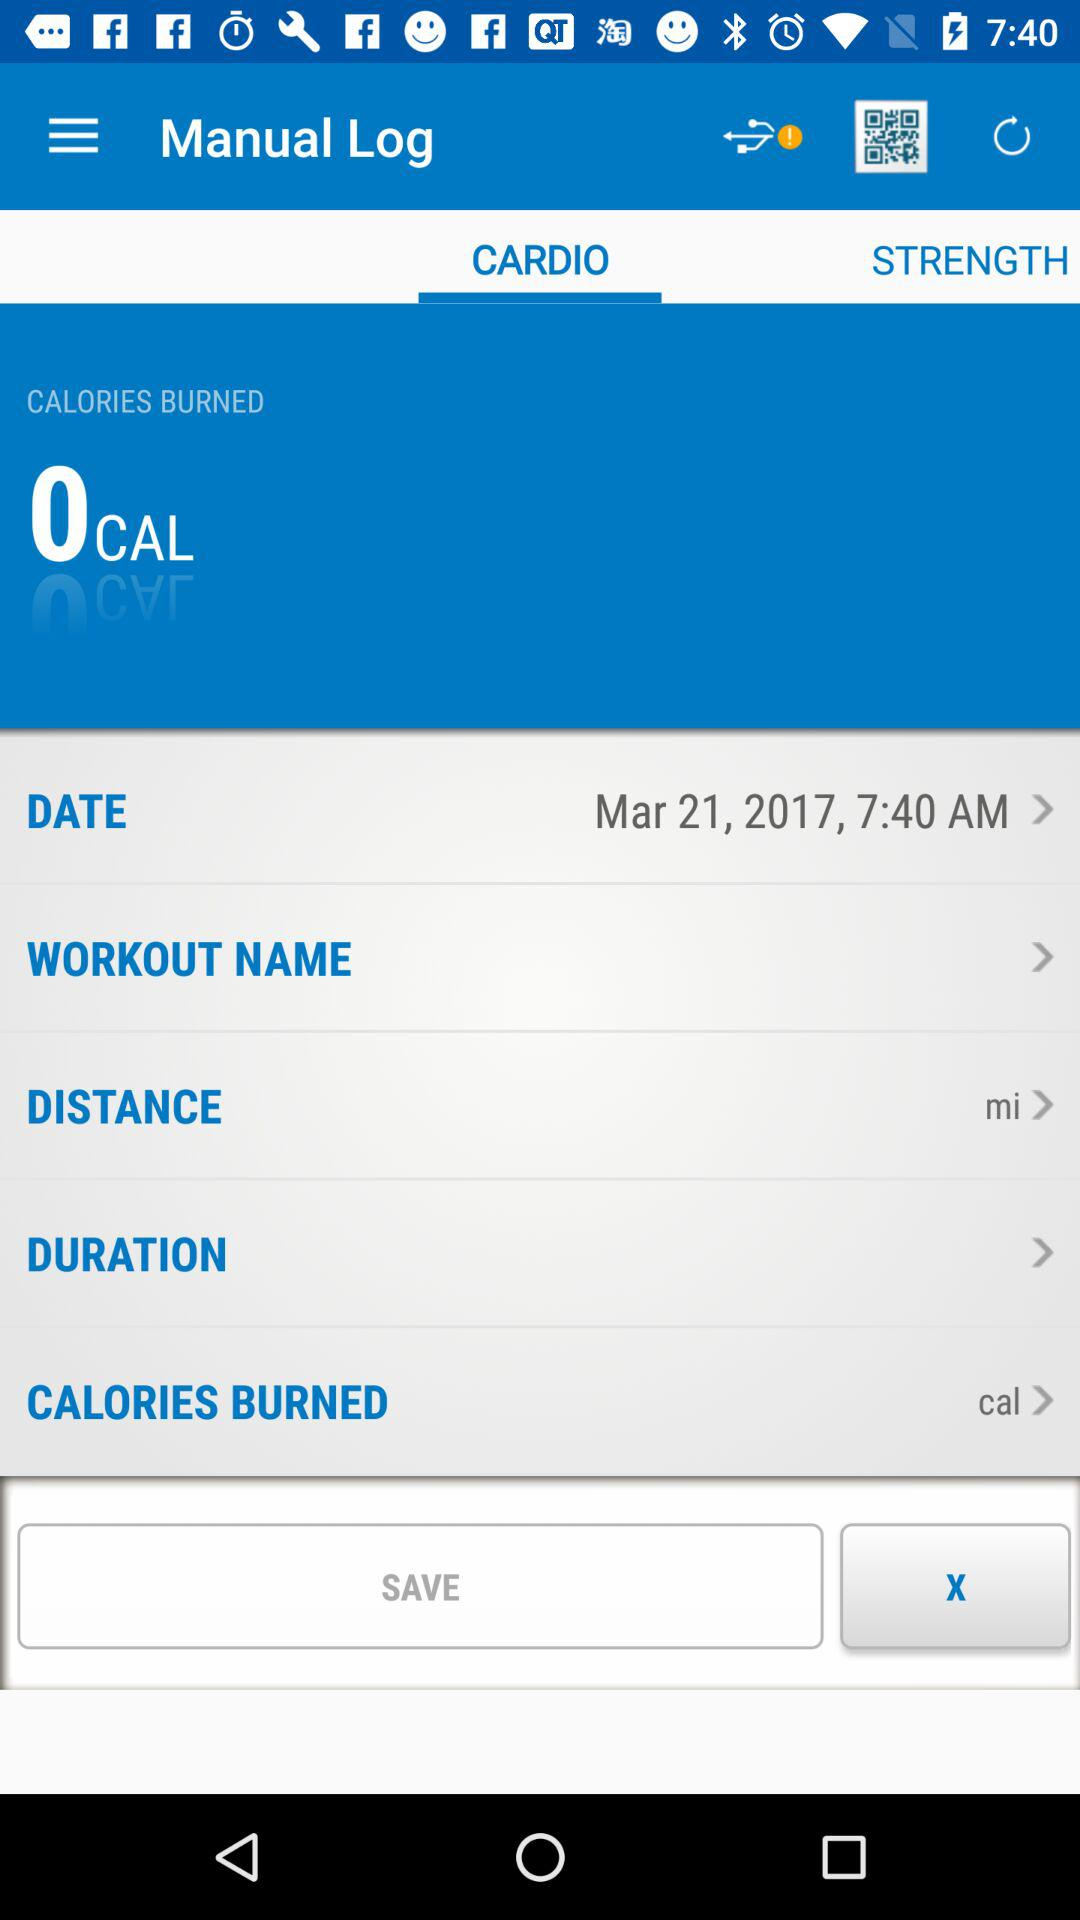How many calories are burned? There are 0 calories burned. 